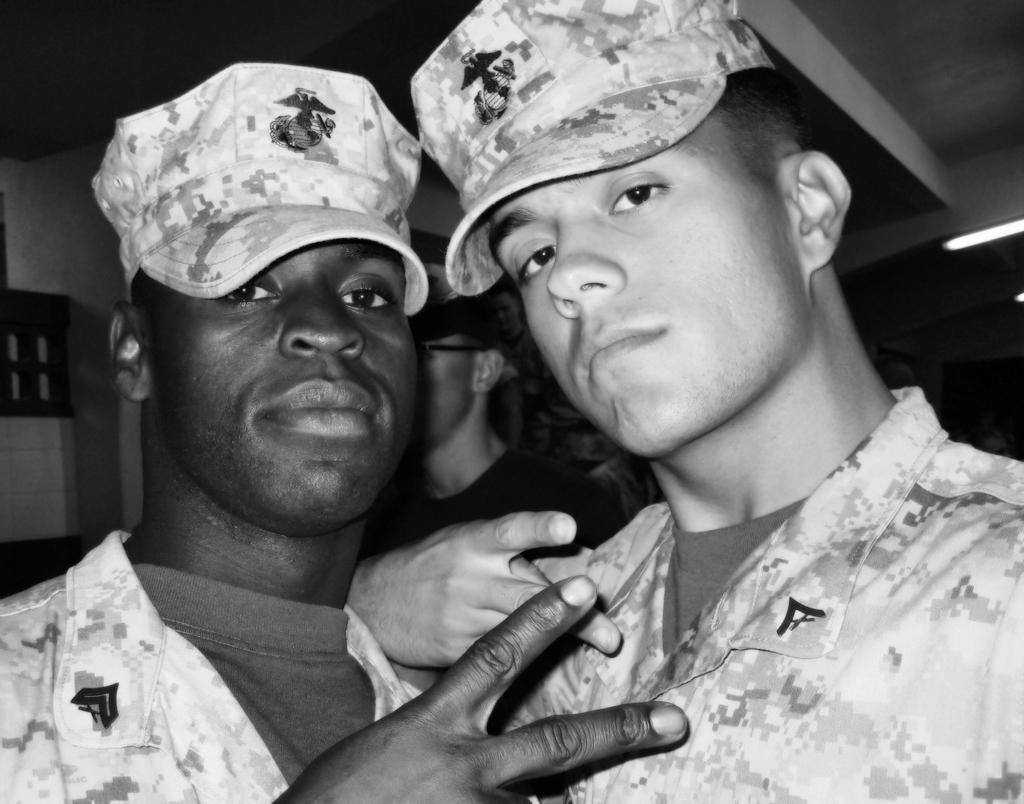How would you summarize this image in a sentence or two? This picture is clicked inside the room. In the foreground we can see the two people wearing uniforms and seems to be standing. In the background we can see the group of people. At the top there is a roof and the light. In the background we can see the wall and many other objects. 